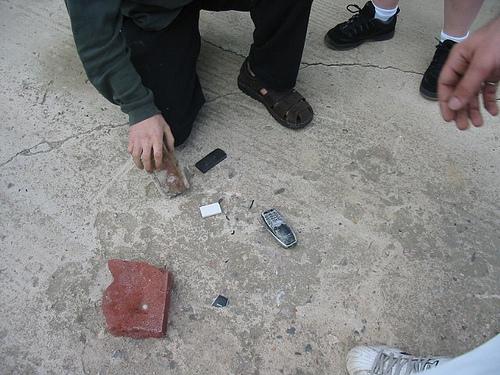What is the man holding in his right hand?
Write a very short answer. Brick. Is the phone broken?
Keep it brief. Yes. Why is the man kneeling?
Give a very brief answer. Pick up phone. 